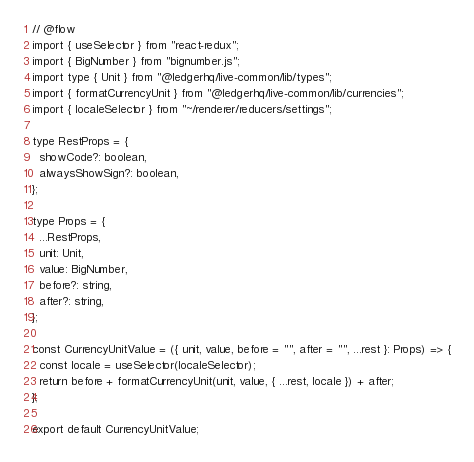Convert code to text. <code><loc_0><loc_0><loc_500><loc_500><_JavaScript_>// @flow
import { useSelector } from "react-redux";
import { BigNumber } from "bignumber.js";
import type { Unit } from "@ledgerhq/live-common/lib/types";
import { formatCurrencyUnit } from "@ledgerhq/live-common/lib/currencies";
import { localeSelector } from "~/renderer/reducers/settings";

type RestProps = {
  showCode?: boolean,
  alwaysShowSign?: boolean,
};

type Props = {
  ...RestProps,
  unit: Unit,
  value: BigNumber,
  before?: string,
  after?: string,
};

const CurrencyUnitValue = ({ unit, value, before = "", after = "", ...rest }: Props) => {
  const locale = useSelector(localeSelector);
  return before + formatCurrencyUnit(unit, value, { ...rest, locale }) + after;
};

export default CurrencyUnitValue;
</code> 